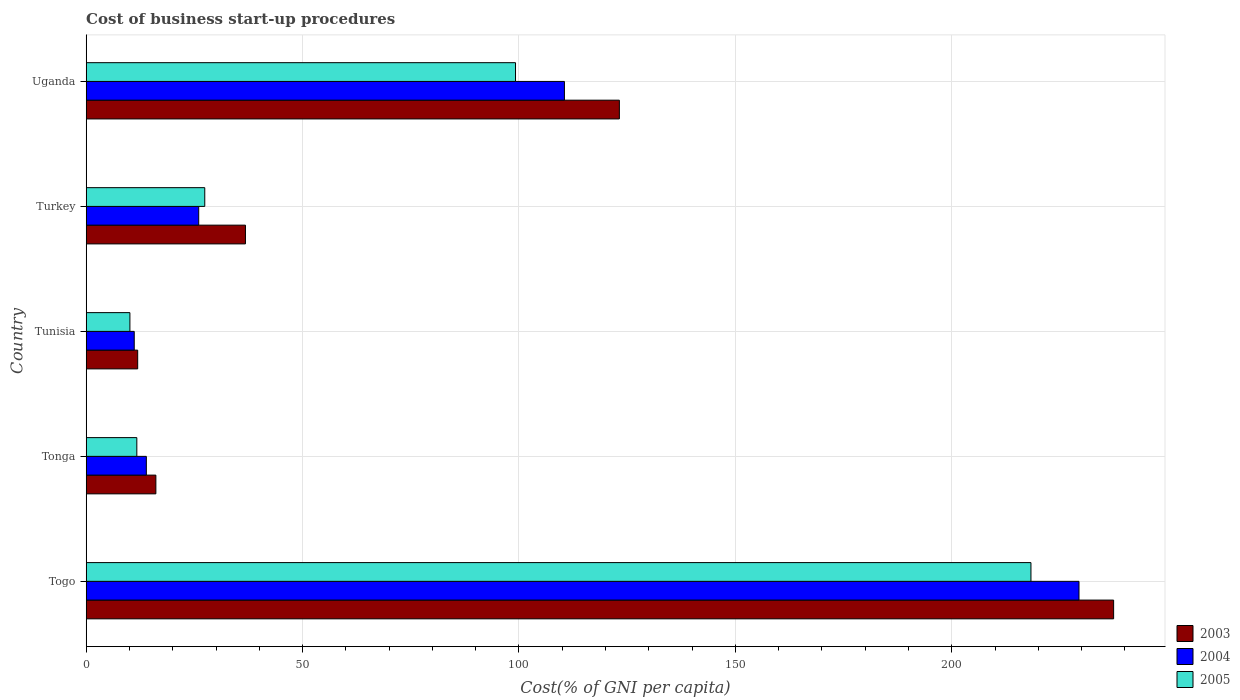How many different coloured bars are there?
Your answer should be compact. 3. How many groups of bars are there?
Your answer should be compact. 5. Are the number of bars per tick equal to the number of legend labels?
Your response must be concise. Yes. Are the number of bars on each tick of the Y-axis equal?
Provide a short and direct response. Yes. How many bars are there on the 4th tick from the bottom?
Provide a succinct answer. 3. What is the label of the 4th group of bars from the top?
Keep it short and to the point. Tonga. Across all countries, what is the maximum cost of business start-up procedures in 2005?
Provide a succinct answer. 218.3. Across all countries, what is the minimum cost of business start-up procedures in 2005?
Your response must be concise. 10.1. In which country was the cost of business start-up procedures in 2004 maximum?
Ensure brevity in your answer.  Togo. In which country was the cost of business start-up procedures in 2003 minimum?
Your answer should be compact. Tunisia. What is the total cost of business start-up procedures in 2003 in the graph?
Offer a very short reply. 425.4. What is the difference between the cost of business start-up procedures in 2004 in Togo and that in Tonga?
Give a very brief answer. 215.5. What is the average cost of business start-up procedures in 2003 per country?
Offer a terse response. 85.08. What is the difference between the cost of business start-up procedures in 2004 and cost of business start-up procedures in 2005 in Uganda?
Your response must be concise. 11.3. In how many countries, is the cost of business start-up procedures in 2004 greater than 150 %?
Your answer should be very brief. 1. What is the ratio of the cost of business start-up procedures in 2004 in Tunisia to that in Turkey?
Give a very brief answer. 0.43. Is the cost of business start-up procedures in 2004 in Togo less than that in Turkey?
Make the answer very short. No. Is the difference between the cost of business start-up procedures in 2004 in Togo and Uganda greater than the difference between the cost of business start-up procedures in 2005 in Togo and Uganda?
Offer a very short reply. No. What is the difference between the highest and the second highest cost of business start-up procedures in 2004?
Make the answer very short. 118.9. What is the difference between the highest and the lowest cost of business start-up procedures in 2004?
Provide a short and direct response. 218.3. In how many countries, is the cost of business start-up procedures in 2005 greater than the average cost of business start-up procedures in 2005 taken over all countries?
Give a very brief answer. 2. What does the 3rd bar from the top in Togo represents?
Offer a very short reply. 2003. What does the 2nd bar from the bottom in Tunisia represents?
Make the answer very short. 2004. Is it the case that in every country, the sum of the cost of business start-up procedures in 2003 and cost of business start-up procedures in 2004 is greater than the cost of business start-up procedures in 2005?
Provide a succinct answer. Yes. How many bars are there?
Your response must be concise. 15. Are all the bars in the graph horizontal?
Ensure brevity in your answer.  Yes. Does the graph contain any zero values?
Give a very brief answer. No. Does the graph contain grids?
Provide a short and direct response. Yes. What is the title of the graph?
Keep it short and to the point. Cost of business start-up procedures. What is the label or title of the X-axis?
Offer a very short reply. Cost(% of GNI per capita). What is the Cost(% of GNI per capita) of 2003 in Togo?
Offer a very short reply. 237.4. What is the Cost(% of GNI per capita) in 2004 in Togo?
Your answer should be compact. 229.4. What is the Cost(% of GNI per capita) of 2005 in Togo?
Offer a very short reply. 218.3. What is the Cost(% of GNI per capita) in 2003 in Tonga?
Give a very brief answer. 16.1. What is the Cost(% of GNI per capita) in 2005 in Tonga?
Provide a succinct answer. 11.7. What is the Cost(% of GNI per capita) of 2003 in Tunisia?
Your response must be concise. 11.9. What is the Cost(% of GNI per capita) in 2005 in Tunisia?
Your response must be concise. 10.1. What is the Cost(% of GNI per capita) of 2003 in Turkey?
Keep it short and to the point. 36.8. What is the Cost(% of GNI per capita) in 2005 in Turkey?
Provide a short and direct response. 27.4. What is the Cost(% of GNI per capita) of 2003 in Uganda?
Offer a terse response. 123.2. What is the Cost(% of GNI per capita) of 2004 in Uganda?
Your answer should be compact. 110.5. What is the Cost(% of GNI per capita) in 2005 in Uganda?
Offer a terse response. 99.2. Across all countries, what is the maximum Cost(% of GNI per capita) of 2003?
Offer a very short reply. 237.4. Across all countries, what is the maximum Cost(% of GNI per capita) of 2004?
Keep it short and to the point. 229.4. Across all countries, what is the maximum Cost(% of GNI per capita) of 2005?
Your answer should be compact. 218.3. Across all countries, what is the minimum Cost(% of GNI per capita) in 2003?
Provide a succinct answer. 11.9. What is the total Cost(% of GNI per capita) in 2003 in the graph?
Give a very brief answer. 425.4. What is the total Cost(% of GNI per capita) in 2004 in the graph?
Keep it short and to the point. 390.9. What is the total Cost(% of GNI per capita) in 2005 in the graph?
Ensure brevity in your answer.  366.7. What is the difference between the Cost(% of GNI per capita) of 2003 in Togo and that in Tonga?
Keep it short and to the point. 221.3. What is the difference between the Cost(% of GNI per capita) in 2004 in Togo and that in Tonga?
Your answer should be very brief. 215.5. What is the difference between the Cost(% of GNI per capita) of 2005 in Togo and that in Tonga?
Provide a short and direct response. 206.6. What is the difference between the Cost(% of GNI per capita) in 2003 in Togo and that in Tunisia?
Your answer should be very brief. 225.5. What is the difference between the Cost(% of GNI per capita) of 2004 in Togo and that in Tunisia?
Your answer should be very brief. 218.3. What is the difference between the Cost(% of GNI per capita) in 2005 in Togo and that in Tunisia?
Your response must be concise. 208.2. What is the difference between the Cost(% of GNI per capita) of 2003 in Togo and that in Turkey?
Your response must be concise. 200.6. What is the difference between the Cost(% of GNI per capita) of 2004 in Togo and that in Turkey?
Provide a short and direct response. 203.4. What is the difference between the Cost(% of GNI per capita) of 2005 in Togo and that in Turkey?
Give a very brief answer. 190.9. What is the difference between the Cost(% of GNI per capita) in 2003 in Togo and that in Uganda?
Make the answer very short. 114.2. What is the difference between the Cost(% of GNI per capita) of 2004 in Togo and that in Uganda?
Your answer should be very brief. 118.9. What is the difference between the Cost(% of GNI per capita) in 2005 in Togo and that in Uganda?
Give a very brief answer. 119.1. What is the difference between the Cost(% of GNI per capita) of 2003 in Tonga and that in Turkey?
Keep it short and to the point. -20.7. What is the difference between the Cost(% of GNI per capita) of 2004 in Tonga and that in Turkey?
Your answer should be compact. -12.1. What is the difference between the Cost(% of GNI per capita) of 2005 in Tonga and that in Turkey?
Provide a short and direct response. -15.7. What is the difference between the Cost(% of GNI per capita) in 2003 in Tonga and that in Uganda?
Provide a short and direct response. -107.1. What is the difference between the Cost(% of GNI per capita) in 2004 in Tonga and that in Uganda?
Give a very brief answer. -96.6. What is the difference between the Cost(% of GNI per capita) of 2005 in Tonga and that in Uganda?
Make the answer very short. -87.5. What is the difference between the Cost(% of GNI per capita) in 2003 in Tunisia and that in Turkey?
Make the answer very short. -24.9. What is the difference between the Cost(% of GNI per capita) in 2004 in Tunisia and that in Turkey?
Give a very brief answer. -14.9. What is the difference between the Cost(% of GNI per capita) of 2005 in Tunisia and that in Turkey?
Give a very brief answer. -17.3. What is the difference between the Cost(% of GNI per capita) in 2003 in Tunisia and that in Uganda?
Your response must be concise. -111.3. What is the difference between the Cost(% of GNI per capita) of 2004 in Tunisia and that in Uganda?
Give a very brief answer. -99.4. What is the difference between the Cost(% of GNI per capita) in 2005 in Tunisia and that in Uganda?
Keep it short and to the point. -89.1. What is the difference between the Cost(% of GNI per capita) of 2003 in Turkey and that in Uganda?
Your answer should be compact. -86.4. What is the difference between the Cost(% of GNI per capita) in 2004 in Turkey and that in Uganda?
Offer a terse response. -84.5. What is the difference between the Cost(% of GNI per capita) in 2005 in Turkey and that in Uganda?
Make the answer very short. -71.8. What is the difference between the Cost(% of GNI per capita) of 2003 in Togo and the Cost(% of GNI per capita) of 2004 in Tonga?
Give a very brief answer. 223.5. What is the difference between the Cost(% of GNI per capita) in 2003 in Togo and the Cost(% of GNI per capita) in 2005 in Tonga?
Give a very brief answer. 225.7. What is the difference between the Cost(% of GNI per capita) in 2004 in Togo and the Cost(% of GNI per capita) in 2005 in Tonga?
Give a very brief answer. 217.7. What is the difference between the Cost(% of GNI per capita) of 2003 in Togo and the Cost(% of GNI per capita) of 2004 in Tunisia?
Give a very brief answer. 226.3. What is the difference between the Cost(% of GNI per capita) of 2003 in Togo and the Cost(% of GNI per capita) of 2005 in Tunisia?
Offer a terse response. 227.3. What is the difference between the Cost(% of GNI per capita) of 2004 in Togo and the Cost(% of GNI per capita) of 2005 in Tunisia?
Keep it short and to the point. 219.3. What is the difference between the Cost(% of GNI per capita) in 2003 in Togo and the Cost(% of GNI per capita) in 2004 in Turkey?
Make the answer very short. 211.4. What is the difference between the Cost(% of GNI per capita) of 2003 in Togo and the Cost(% of GNI per capita) of 2005 in Turkey?
Make the answer very short. 210. What is the difference between the Cost(% of GNI per capita) in 2004 in Togo and the Cost(% of GNI per capita) in 2005 in Turkey?
Keep it short and to the point. 202. What is the difference between the Cost(% of GNI per capita) of 2003 in Togo and the Cost(% of GNI per capita) of 2004 in Uganda?
Offer a very short reply. 126.9. What is the difference between the Cost(% of GNI per capita) of 2003 in Togo and the Cost(% of GNI per capita) of 2005 in Uganda?
Your answer should be compact. 138.2. What is the difference between the Cost(% of GNI per capita) of 2004 in Togo and the Cost(% of GNI per capita) of 2005 in Uganda?
Keep it short and to the point. 130.2. What is the difference between the Cost(% of GNI per capita) of 2004 in Tonga and the Cost(% of GNI per capita) of 2005 in Tunisia?
Make the answer very short. 3.8. What is the difference between the Cost(% of GNI per capita) of 2003 in Tonga and the Cost(% of GNI per capita) of 2005 in Turkey?
Your response must be concise. -11.3. What is the difference between the Cost(% of GNI per capita) of 2003 in Tonga and the Cost(% of GNI per capita) of 2004 in Uganda?
Provide a succinct answer. -94.4. What is the difference between the Cost(% of GNI per capita) of 2003 in Tonga and the Cost(% of GNI per capita) of 2005 in Uganda?
Your answer should be very brief. -83.1. What is the difference between the Cost(% of GNI per capita) of 2004 in Tonga and the Cost(% of GNI per capita) of 2005 in Uganda?
Give a very brief answer. -85.3. What is the difference between the Cost(% of GNI per capita) in 2003 in Tunisia and the Cost(% of GNI per capita) in 2004 in Turkey?
Offer a terse response. -14.1. What is the difference between the Cost(% of GNI per capita) of 2003 in Tunisia and the Cost(% of GNI per capita) of 2005 in Turkey?
Your answer should be compact. -15.5. What is the difference between the Cost(% of GNI per capita) in 2004 in Tunisia and the Cost(% of GNI per capita) in 2005 in Turkey?
Provide a succinct answer. -16.3. What is the difference between the Cost(% of GNI per capita) of 2003 in Tunisia and the Cost(% of GNI per capita) of 2004 in Uganda?
Make the answer very short. -98.6. What is the difference between the Cost(% of GNI per capita) of 2003 in Tunisia and the Cost(% of GNI per capita) of 2005 in Uganda?
Give a very brief answer. -87.3. What is the difference between the Cost(% of GNI per capita) of 2004 in Tunisia and the Cost(% of GNI per capita) of 2005 in Uganda?
Provide a succinct answer. -88.1. What is the difference between the Cost(% of GNI per capita) of 2003 in Turkey and the Cost(% of GNI per capita) of 2004 in Uganda?
Provide a succinct answer. -73.7. What is the difference between the Cost(% of GNI per capita) in 2003 in Turkey and the Cost(% of GNI per capita) in 2005 in Uganda?
Make the answer very short. -62.4. What is the difference between the Cost(% of GNI per capita) in 2004 in Turkey and the Cost(% of GNI per capita) in 2005 in Uganda?
Provide a short and direct response. -73.2. What is the average Cost(% of GNI per capita) of 2003 per country?
Keep it short and to the point. 85.08. What is the average Cost(% of GNI per capita) in 2004 per country?
Make the answer very short. 78.18. What is the average Cost(% of GNI per capita) of 2005 per country?
Ensure brevity in your answer.  73.34. What is the difference between the Cost(% of GNI per capita) of 2003 and Cost(% of GNI per capita) of 2004 in Togo?
Your answer should be compact. 8. What is the difference between the Cost(% of GNI per capita) of 2003 and Cost(% of GNI per capita) of 2005 in Togo?
Offer a terse response. 19.1. What is the difference between the Cost(% of GNI per capita) of 2003 and Cost(% of GNI per capita) of 2004 in Tonga?
Keep it short and to the point. 2.2. What is the difference between the Cost(% of GNI per capita) of 2004 and Cost(% of GNI per capita) of 2005 in Tonga?
Make the answer very short. 2.2. What is the difference between the Cost(% of GNI per capita) in 2003 and Cost(% of GNI per capita) in 2004 in Tunisia?
Keep it short and to the point. 0.8. What is the difference between the Cost(% of GNI per capita) in 2003 and Cost(% of GNI per capita) in 2005 in Tunisia?
Your answer should be very brief. 1.8. What is the difference between the Cost(% of GNI per capita) of 2004 and Cost(% of GNI per capita) of 2005 in Tunisia?
Ensure brevity in your answer.  1. What is the difference between the Cost(% of GNI per capita) of 2004 and Cost(% of GNI per capita) of 2005 in Turkey?
Offer a very short reply. -1.4. What is the difference between the Cost(% of GNI per capita) in 2003 and Cost(% of GNI per capita) in 2004 in Uganda?
Make the answer very short. 12.7. What is the difference between the Cost(% of GNI per capita) of 2003 and Cost(% of GNI per capita) of 2005 in Uganda?
Your answer should be compact. 24. What is the ratio of the Cost(% of GNI per capita) of 2003 in Togo to that in Tonga?
Give a very brief answer. 14.75. What is the ratio of the Cost(% of GNI per capita) of 2004 in Togo to that in Tonga?
Your answer should be very brief. 16.5. What is the ratio of the Cost(% of GNI per capita) of 2005 in Togo to that in Tonga?
Ensure brevity in your answer.  18.66. What is the ratio of the Cost(% of GNI per capita) of 2003 in Togo to that in Tunisia?
Provide a short and direct response. 19.95. What is the ratio of the Cost(% of GNI per capita) of 2004 in Togo to that in Tunisia?
Offer a very short reply. 20.67. What is the ratio of the Cost(% of GNI per capita) in 2005 in Togo to that in Tunisia?
Your answer should be very brief. 21.61. What is the ratio of the Cost(% of GNI per capita) of 2003 in Togo to that in Turkey?
Your answer should be compact. 6.45. What is the ratio of the Cost(% of GNI per capita) in 2004 in Togo to that in Turkey?
Your answer should be compact. 8.82. What is the ratio of the Cost(% of GNI per capita) of 2005 in Togo to that in Turkey?
Provide a short and direct response. 7.97. What is the ratio of the Cost(% of GNI per capita) of 2003 in Togo to that in Uganda?
Make the answer very short. 1.93. What is the ratio of the Cost(% of GNI per capita) of 2004 in Togo to that in Uganda?
Offer a terse response. 2.08. What is the ratio of the Cost(% of GNI per capita) of 2005 in Togo to that in Uganda?
Offer a very short reply. 2.2. What is the ratio of the Cost(% of GNI per capita) of 2003 in Tonga to that in Tunisia?
Offer a very short reply. 1.35. What is the ratio of the Cost(% of GNI per capita) of 2004 in Tonga to that in Tunisia?
Give a very brief answer. 1.25. What is the ratio of the Cost(% of GNI per capita) in 2005 in Tonga to that in Tunisia?
Keep it short and to the point. 1.16. What is the ratio of the Cost(% of GNI per capita) of 2003 in Tonga to that in Turkey?
Your response must be concise. 0.44. What is the ratio of the Cost(% of GNI per capita) in 2004 in Tonga to that in Turkey?
Provide a short and direct response. 0.53. What is the ratio of the Cost(% of GNI per capita) in 2005 in Tonga to that in Turkey?
Ensure brevity in your answer.  0.43. What is the ratio of the Cost(% of GNI per capita) of 2003 in Tonga to that in Uganda?
Offer a very short reply. 0.13. What is the ratio of the Cost(% of GNI per capita) of 2004 in Tonga to that in Uganda?
Make the answer very short. 0.13. What is the ratio of the Cost(% of GNI per capita) in 2005 in Tonga to that in Uganda?
Your answer should be compact. 0.12. What is the ratio of the Cost(% of GNI per capita) in 2003 in Tunisia to that in Turkey?
Your response must be concise. 0.32. What is the ratio of the Cost(% of GNI per capita) in 2004 in Tunisia to that in Turkey?
Keep it short and to the point. 0.43. What is the ratio of the Cost(% of GNI per capita) of 2005 in Tunisia to that in Turkey?
Keep it short and to the point. 0.37. What is the ratio of the Cost(% of GNI per capita) in 2003 in Tunisia to that in Uganda?
Your answer should be compact. 0.1. What is the ratio of the Cost(% of GNI per capita) of 2004 in Tunisia to that in Uganda?
Your answer should be very brief. 0.1. What is the ratio of the Cost(% of GNI per capita) of 2005 in Tunisia to that in Uganda?
Provide a short and direct response. 0.1. What is the ratio of the Cost(% of GNI per capita) in 2003 in Turkey to that in Uganda?
Your response must be concise. 0.3. What is the ratio of the Cost(% of GNI per capita) in 2004 in Turkey to that in Uganda?
Your answer should be very brief. 0.24. What is the ratio of the Cost(% of GNI per capita) in 2005 in Turkey to that in Uganda?
Ensure brevity in your answer.  0.28. What is the difference between the highest and the second highest Cost(% of GNI per capita) of 2003?
Provide a succinct answer. 114.2. What is the difference between the highest and the second highest Cost(% of GNI per capita) of 2004?
Offer a terse response. 118.9. What is the difference between the highest and the second highest Cost(% of GNI per capita) of 2005?
Give a very brief answer. 119.1. What is the difference between the highest and the lowest Cost(% of GNI per capita) of 2003?
Make the answer very short. 225.5. What is the difference between the highest and the lowest Cost(% of GNI per capita) in 2004?
Your response must be concise. 218.3. What is the difference between the highest and the lowest Cost(% of GNI per capita) of 2005?
Offer a very short reply. 208.2. 